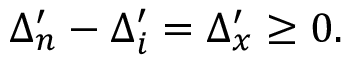<formula> <loc_0><loc_0><loc_500><loc_500>\Delta _ { n } ^ { \prime } - \Delta _ { i } ^ { \prime } = \Delta _ { x } ^ { \prime } \geq 0 .</formula> 